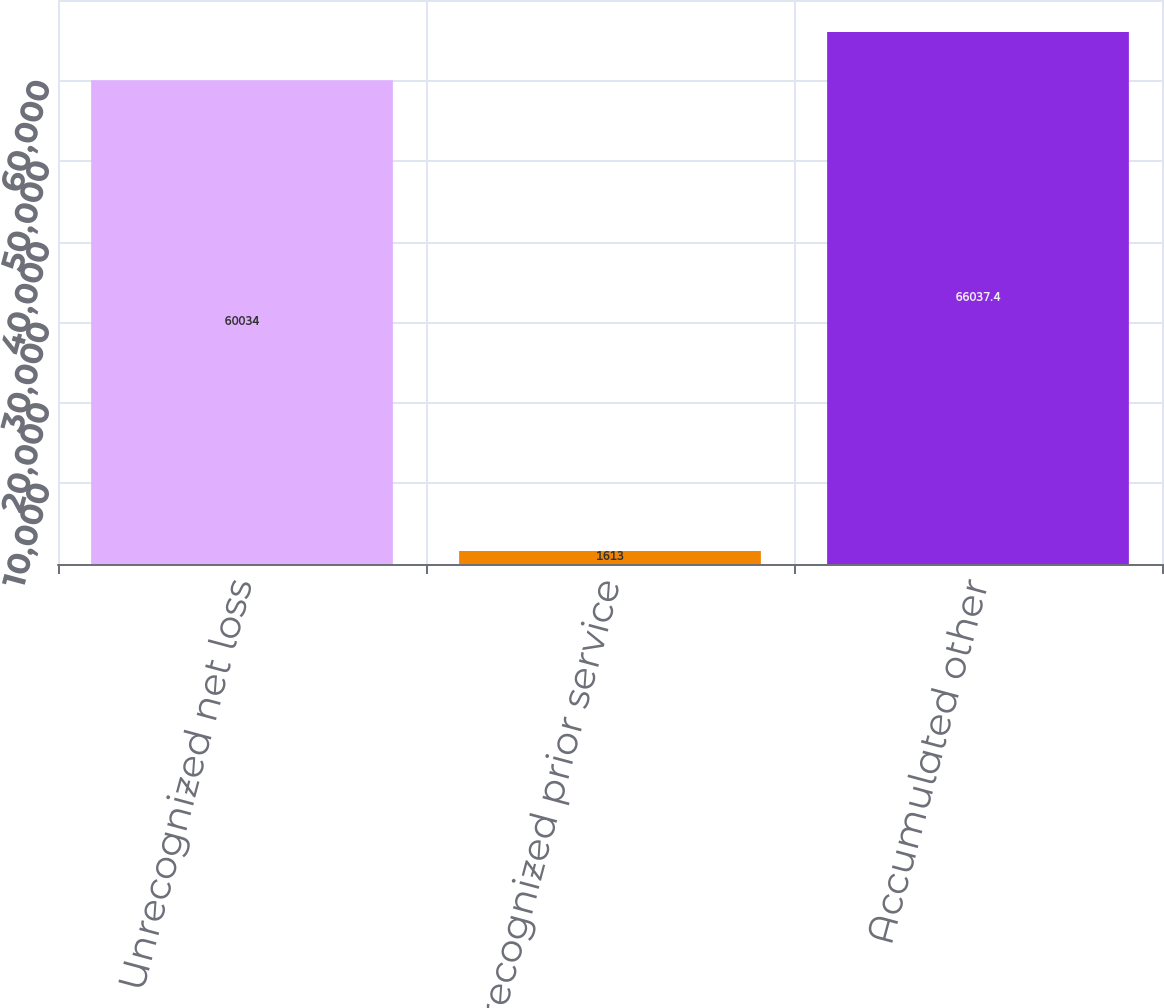Convert chart to OTSL. <chart><loc_0><loc_0><loc_500><loc_500><bar_chart><fcel>Unrecognized net loss<fcel>Unrecognized prior service<fcel>Accumulated other<nl><fcel>60034<fcel>1613<fcel>66037.4<nl></chart> 